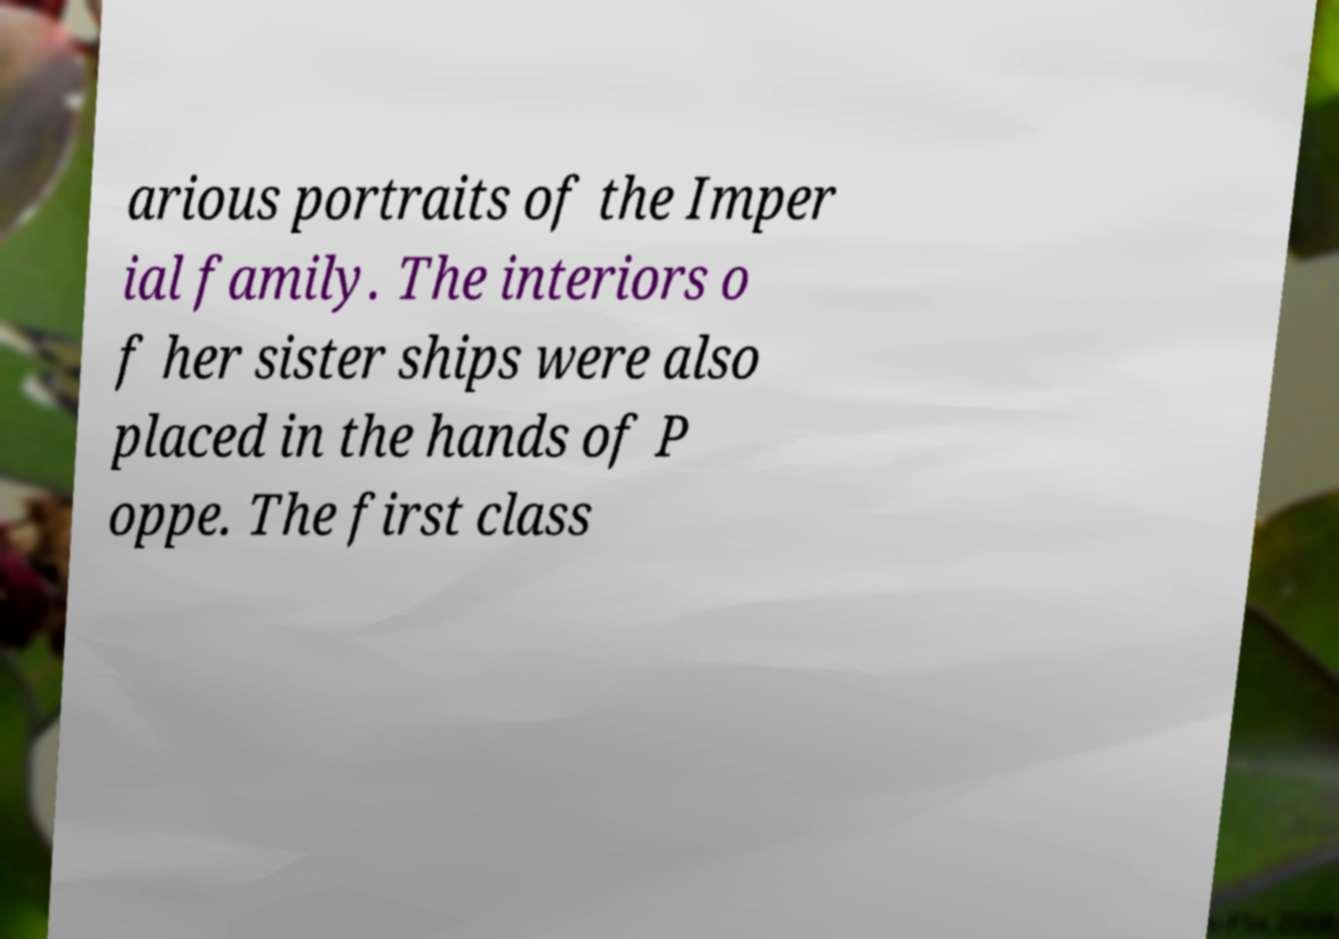Could you extract and type out the text from this image? arious portraits of the Imper ial family. The interiors o f her sister ships were also placed in the hands of P oppe. The first class 